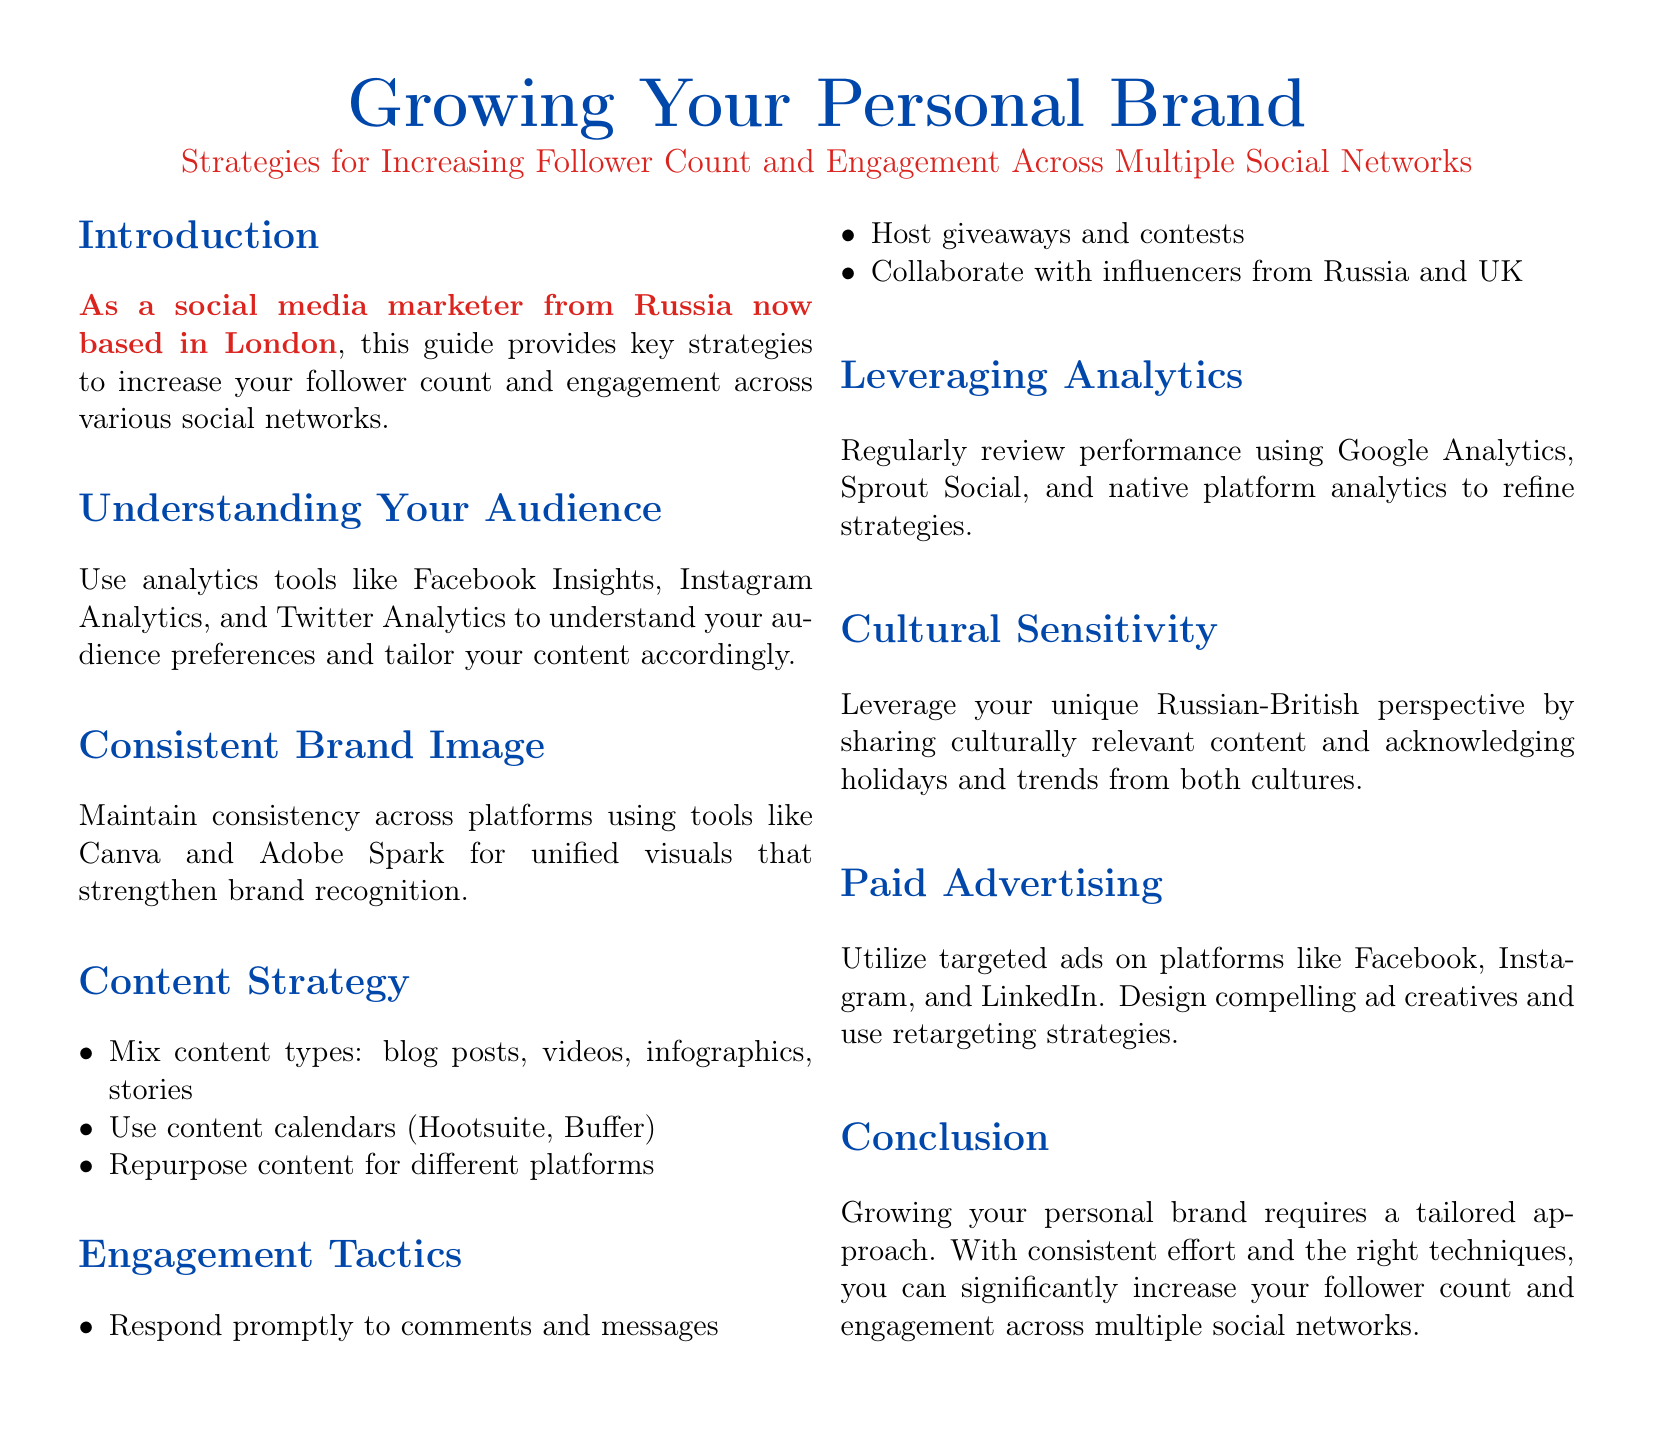What is the main topic of the guide? The document is centered around strategies for enhancing personal branding on social networks.
Answer: Growing Your Personal Brand Which social media analytics tool is mentioned? The guide suggests using various analytics tools to understand audience preferences.
Answer: Facebook Insights What is one tip for maintaining brand consistency? The guide recommends tools that can help ensure unified visuals across platforms.
Answer: Canva How many content types should you mix according to the content strategy? The document indicates a variety of content types should be incorporated.
Answer: Four What is a suggested method to engage with your audience? One of the engagement tactics outlined involves interacting promptly with followers.
Answer: Respond promptly Name a tool for scheduling content. The guide mentions tools designed for content planning and scheduling.
Answer: Hootsuite What cultural aspect should be leveraged in content creation? The document emphasizes being sensitive to cultural nuances while creating content.
Answer: Cultural relevance What type of advertising is recommended? The guide discusses engaging in advertisement efforts to boost visibility and reach.
Answer: Targeted ads What is the role of analytics in personal branding? Regular review of performance analytics helps refine branding strategies according to the document.
Answer: Refine strategies 